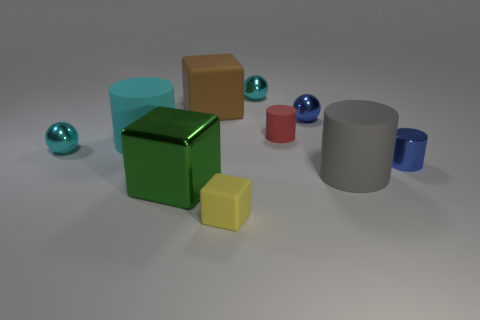Subtract all small cyan spheres. How many spheres are left? 1 Subtract all blue spheres. How many spheres are left? 2 Subtract 4 cylinders. How many cylinders are left? 0 Subtract all cylinders. How many objects are left? 6 Subtract all purple cubes. How many cyan balls are left? 2 Subtract 0 purple cylinders. How many objects are left? 10 Subtract all yellow spheres. Subtract all green cylinders. How many spheres are left? 3 Subtract all large cubes. Subtract all small cyan metal objects. How many objects are left? 6 Add 8 yellow rubber blocks. How many yellow rubber blocks are left? 9 Add 4 purple rubber balls. How many purple rubber balls exist? 4 